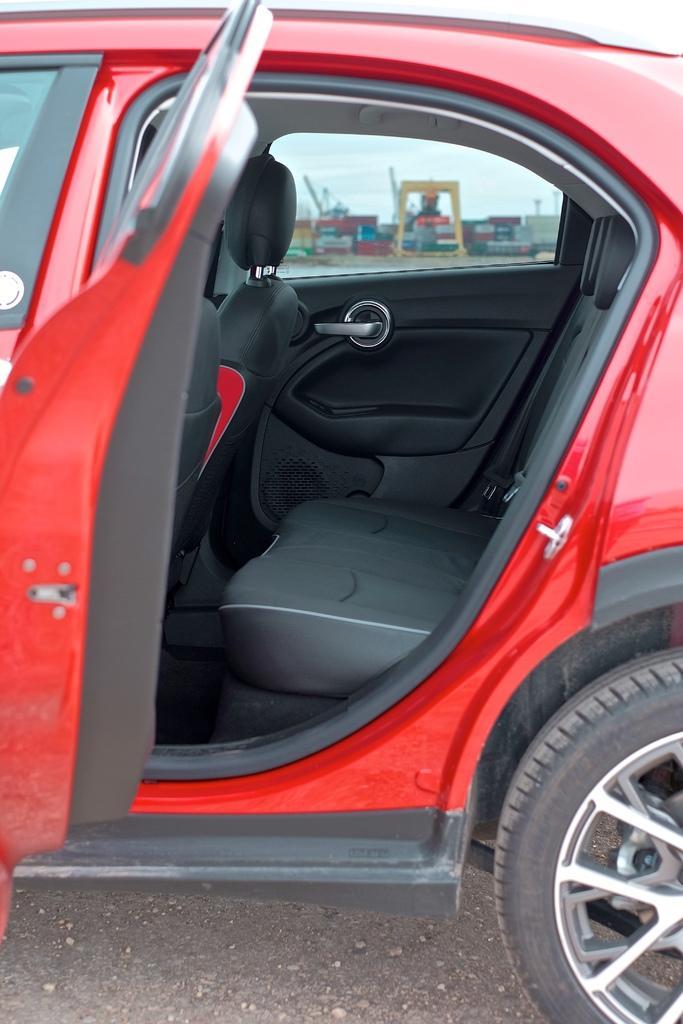How would you summarize this image in a sentence or two? This picture contains a red car which is parked on the road. We see the door of the car is opened. From the window of the car, we see the white wall and many posters pasted on the white wall. We even see the sky. 